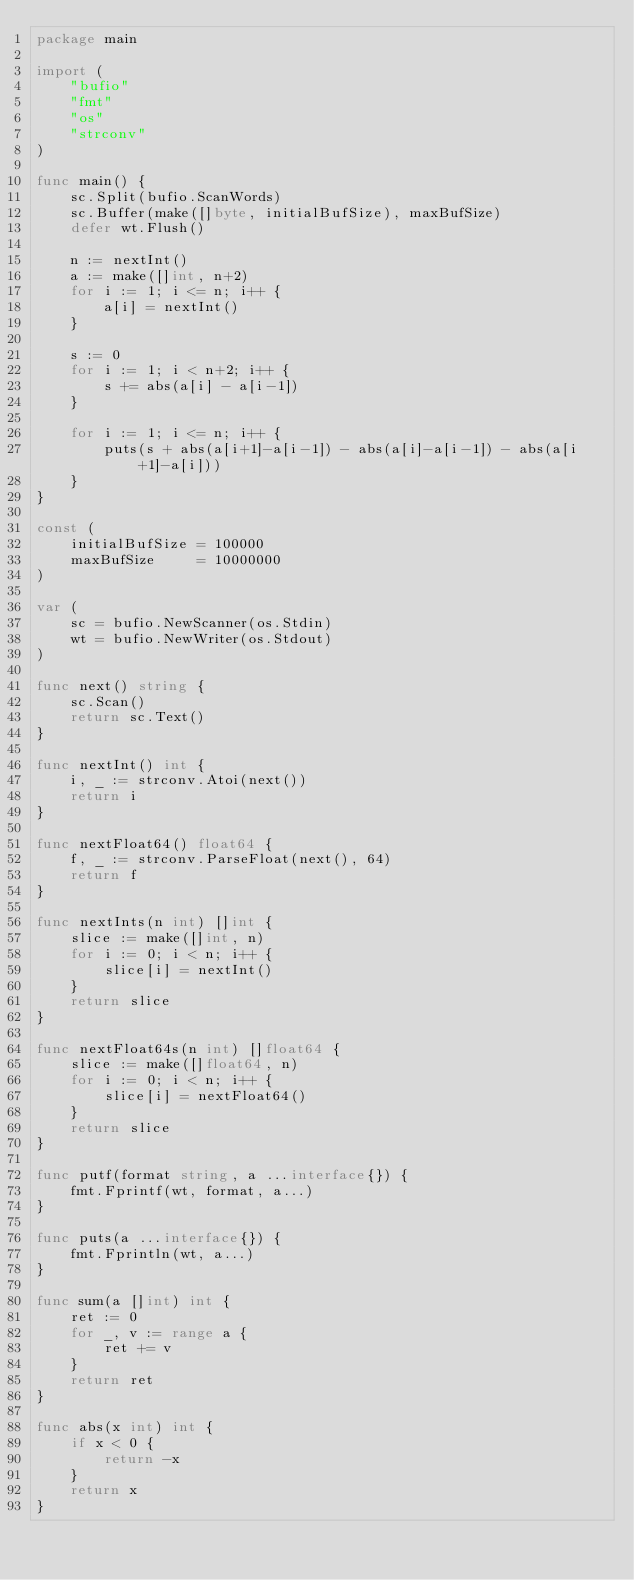Convert code to text. <code><loc_0><loc_0><loc_500><loc_500><_Go_>package main

import (
	"bufio"
	"fmt"
	"os"
	"strconv"
)

func main() {
	sc.Split(bufio.ScanWords)
	sc.Buffer(make([]byte, initialBufSize), maxBufSize)
	defer wt.Flush()

	n := nextInt()
	a := make([]int, n+2)
	for i := 1; i <= n; i++ {
		a[i] = nextInt()
	}

	s := 0
	for i := 1; i < n+2; i++ {
		s += abs(a[i] - a[i-1])
	}

	for i := 1; i <= n; i++ {
		puts(s + abs(a[i+1]-a[i-1]) - abs(a[i]-a[i-1]) - abs(a[i+1]-a[i]))
	}
}

const (
	initialBufSize = 100000
	maxBufSize     = 10000000
)

var (
	sc = bufio.NewScanner(os.Stdin)
	wt = bufio.NewWriter(os.Stdout)
)

func next() string {
	sc.Scan()
	return sc.Text()
}

func nextInt() int {
	i, _ := strconv.Atoi(next())
	return i
}

func nextFloat64() float64 {
	f, _ := strconv.ParseFloat(next(), 64)
	return f
}

func nextInts(n int) []int {
	slice := make([]int, n)
	for i := 0; i < n; i++ {
		slice[i] = nextInt()
	}
	return slice
}

func nextFloat64s(n int) []float64 {
	slice := make([]float64, n)
	for i := 0; i < n; i++ {
		slice[i] = nextFloat64()
	}
	return slice
}

func putf(format string, a ...interface{}) {
	fmt.Fprintf(wt, format, a...)
}

func puts(a ...interface{}) {
	fmt.Fprintln(wt, a...)
}

func sum(a []int) int {
	ret := 0
	for _, v := range a {
		ret += v
	}
	return ret
}

func abs(x int) int {
	if x < 0 {
		return -x
	}
	return x
}
</code> 